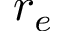<formula> <loc_0><loc_0><loc_500><loc_500>r _ { e }</formula> 